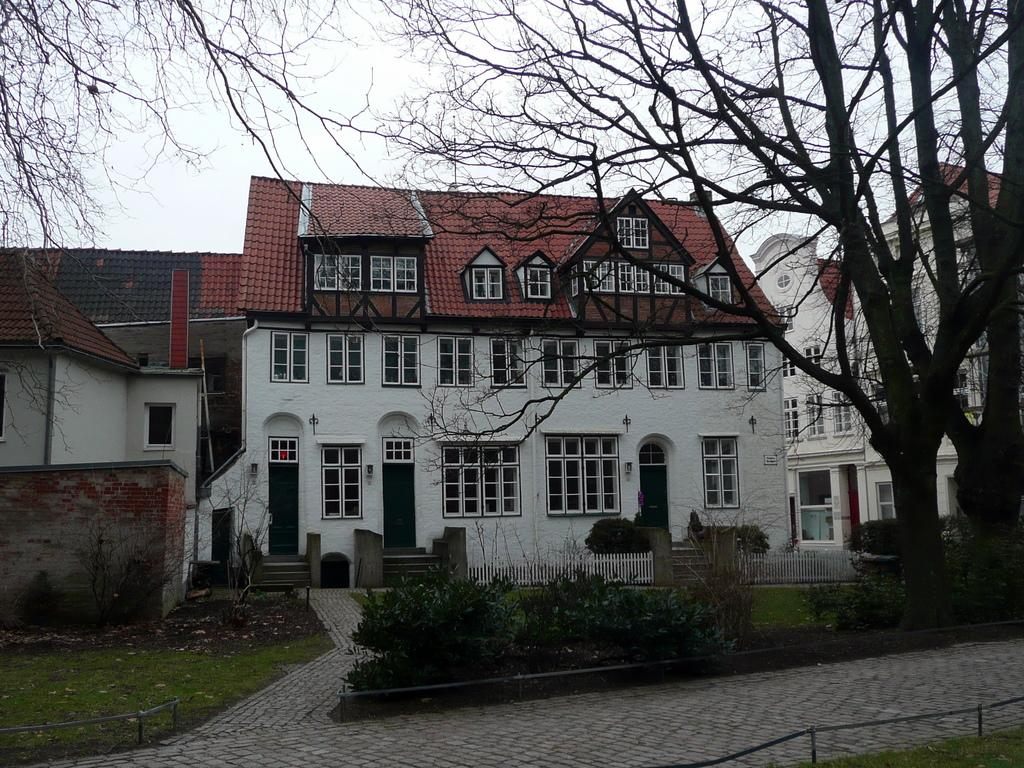What type of structures can be seen in the image? There are buildings in the image. What can be found on the right side of the image? There are trees on the right side of the image. What other types of vegetation are present in the image? There are plants in the image. What is the ground covered with in the image? There is grass in the image. What type of fencing is located beside the stairs? There is wooden fencing beside the stairs. What is visible at the top of the image? The sky is visible at the top of the image. Can you see a train passing by in the image? There is no train present in the image. What color is the pencil used to draw the hill in the image? There is no hill or pencil present in the image. 